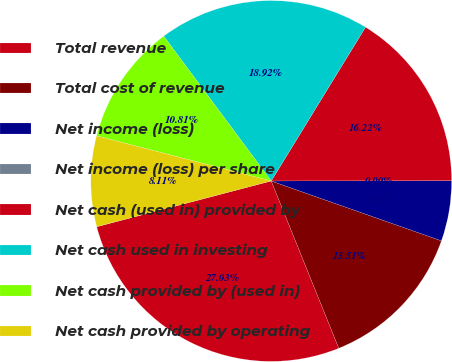<chart> <loc_0><loc_0><loc_500><loc_500><pie_chart><fcel>Total revenue<fcel>Total cost of revenue<fcel>Net income (loss)<fcel>Net income (loss) per share<fcel>Net cash (used in) provided by<fcel>Net cash used in investing<fcel>Net cash provided by (used in)<fcel>Net cash provided by operating<nl><fcel>27.03%<fcel>13.51%<fcel>5.41%<fcel>0.0%<fcel>16.22%<fcel>18.92%<fcel>10.81%<fcel>8.11%<nl></chart> 